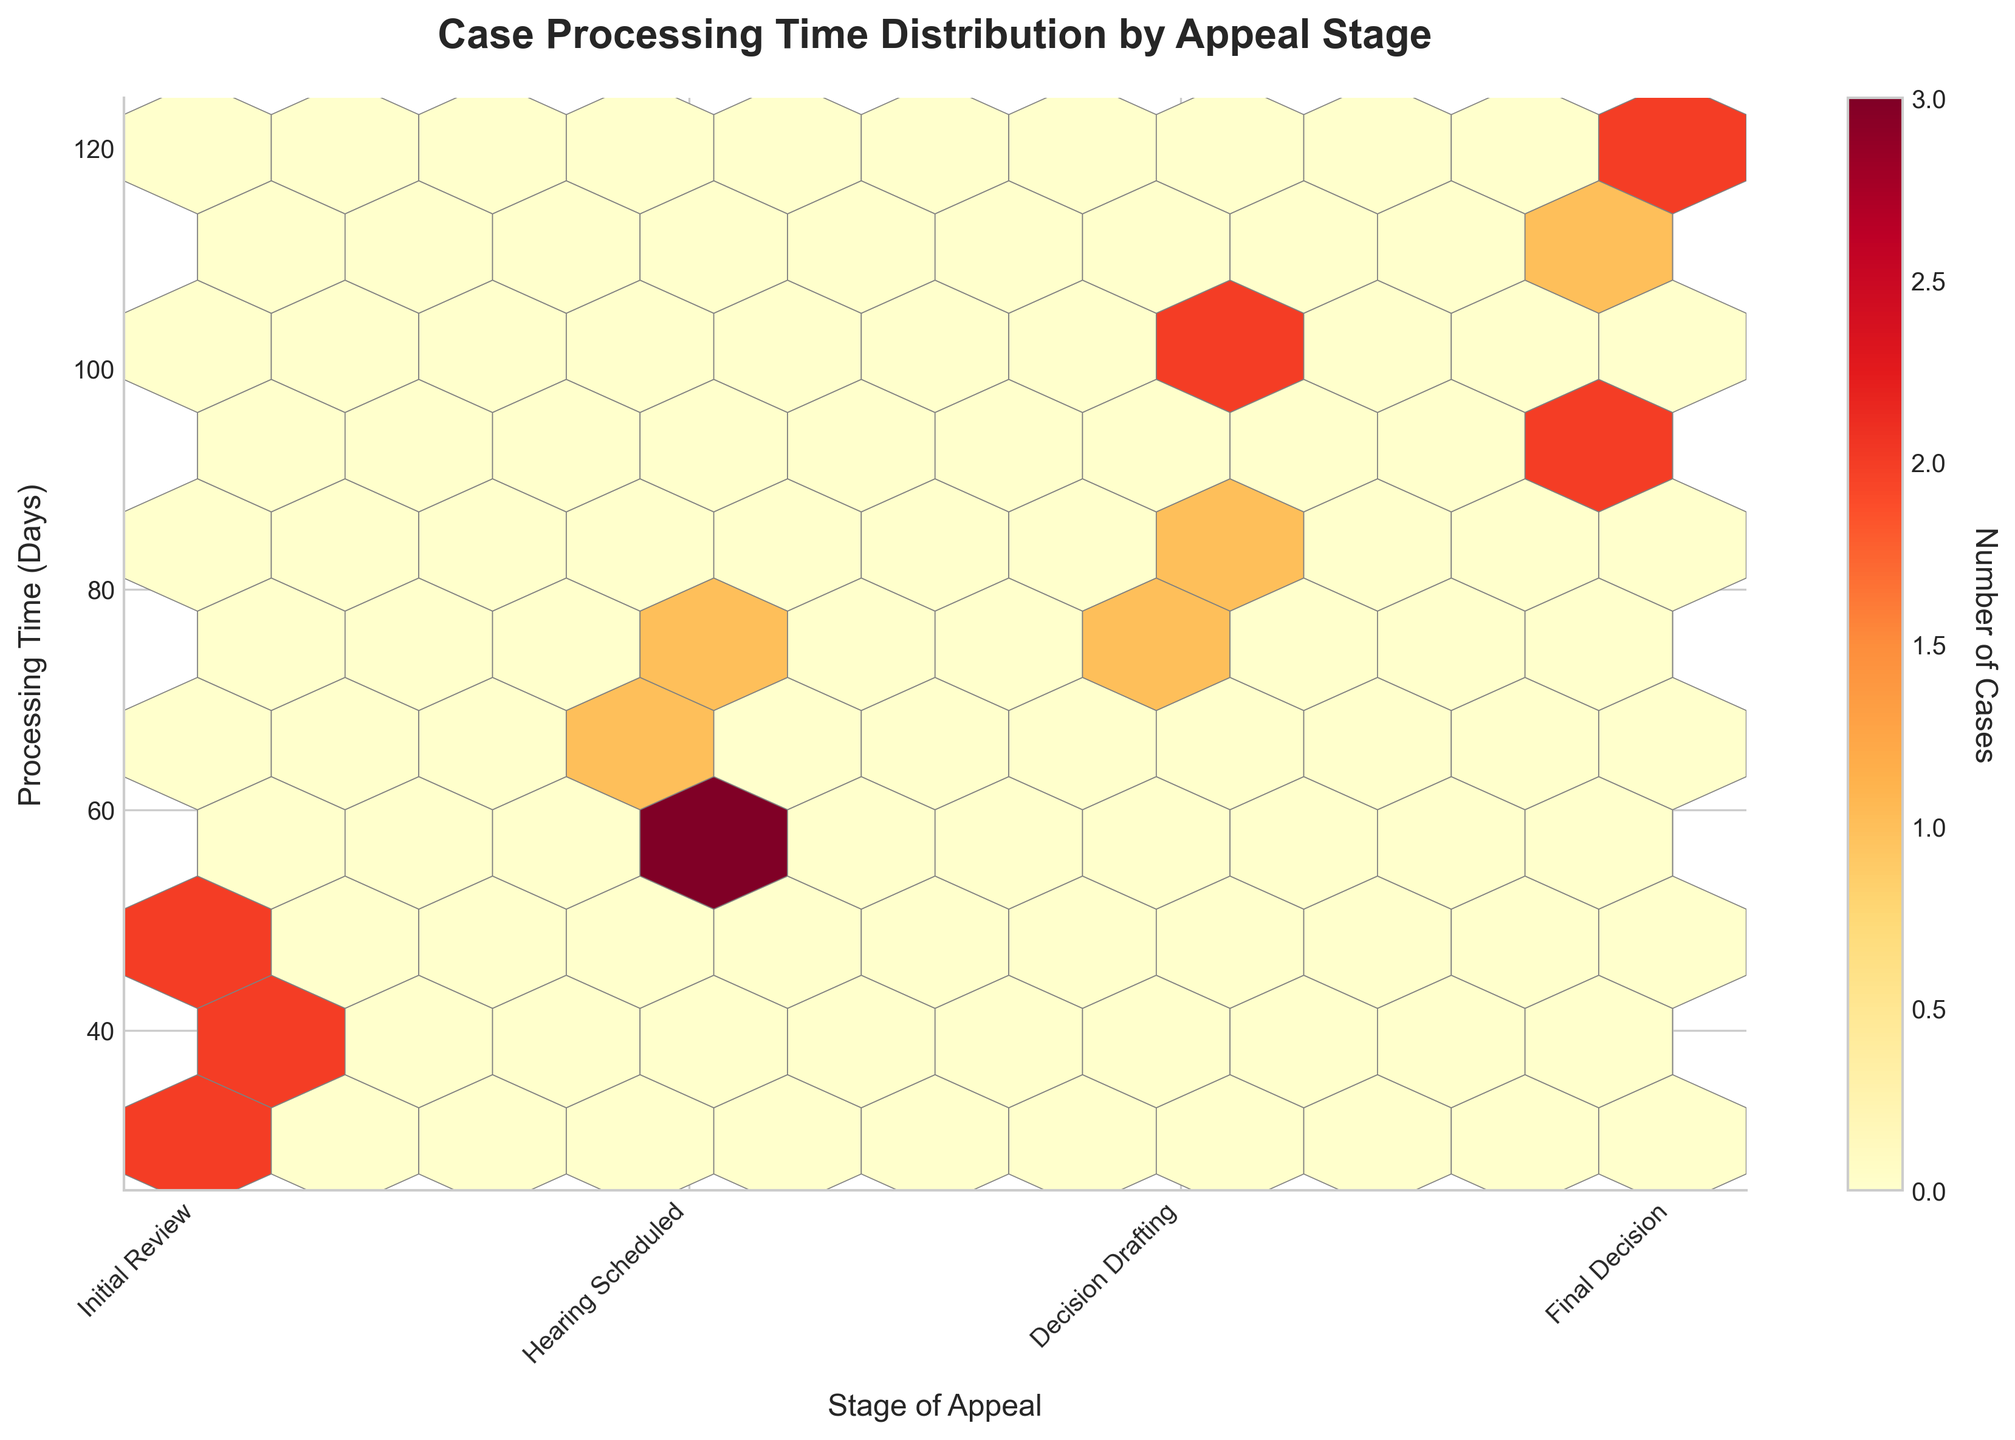What is the title of the hexbin plot? The title of the plot is displayed at the top. It reads "Case Processing Time Distribution by Appeal Stage".
Answer: Case Processing Time Distribution by Appeal Stage How many stages of appeal are labeled on the x-axis? There are four stages of appeal labeled on the x-axis. Specifically, they are "Initial Review", "Hearing Scheduled", "Decision Drafting", and "Final Decision".
Answer: Four Which stage of appeal has the highest number of cases with processing times around 60-70 days? By observing the color density in the hexbin plot, "Hearing Scheduled" has the highest concentration of hexagons with processing times around 60-70 days.
Answer: Hearing Scheduled What is the processing time range that has the highest number of cases for the "Final Decision" stage? The color density of the hexagons in the "Final Decision" stage indicates the highest number of cases are in the processing time range of approximately 100-120 days.
Answer: 100-120 days Which stage appears to have the most variability in processing times? The stage with the most variability has hexagons spread out over a larger range of processing times. The "Final Decision" stage shows the most spread, indicating higher variability.
Answer: Final Decision At which stage does the processing time peak occur? By looking at the densest grouping of hexagons, the processing time peak occurs at the "Hearing Scheduled" stage, around 60-70 days.
Answer: Hearing Scheduled How are the cases distributed across the stages of appeal in terms of processing time? By examining the color intensity and spread of the hexagons, cases in "Initial Review" vary from 30 to 50 days, "Hearing Scheduled" from 55 to 75 days, "Decision Drafting" from 78 to 105 days, and "Final Decision" from 90 to 120 days.
Answer: Distributed as follows Which stage has the fewest number of cases with processing times over 90 days? The "Initial Review" stage has the fewest number of cases with processing times exceeding 90 days as there are no hexagons in that range for this stage.
Answer: Initial Review How does the processing time for "Decision Drafting" compare to "Hearing Scheduled" in terms of range? "Decision Drafting" has a processing time range of 78 to 105 days, while "Hearing Scheduled" has a range from 55 to 75 days, indicating that "Decision Drafting" generally takes longer.
Answer: "Decision Drafting" takes longer Is there a stage where there is a noticeable absence of cases below 50 days? Observing the hexbin plot, there are no hexagons for the "Decision Drafting" and "Final Decision" stages below 50 days, indicating no cases processed in this timeframe for these stages.
Answer: Decision Drafting and Final Decision 